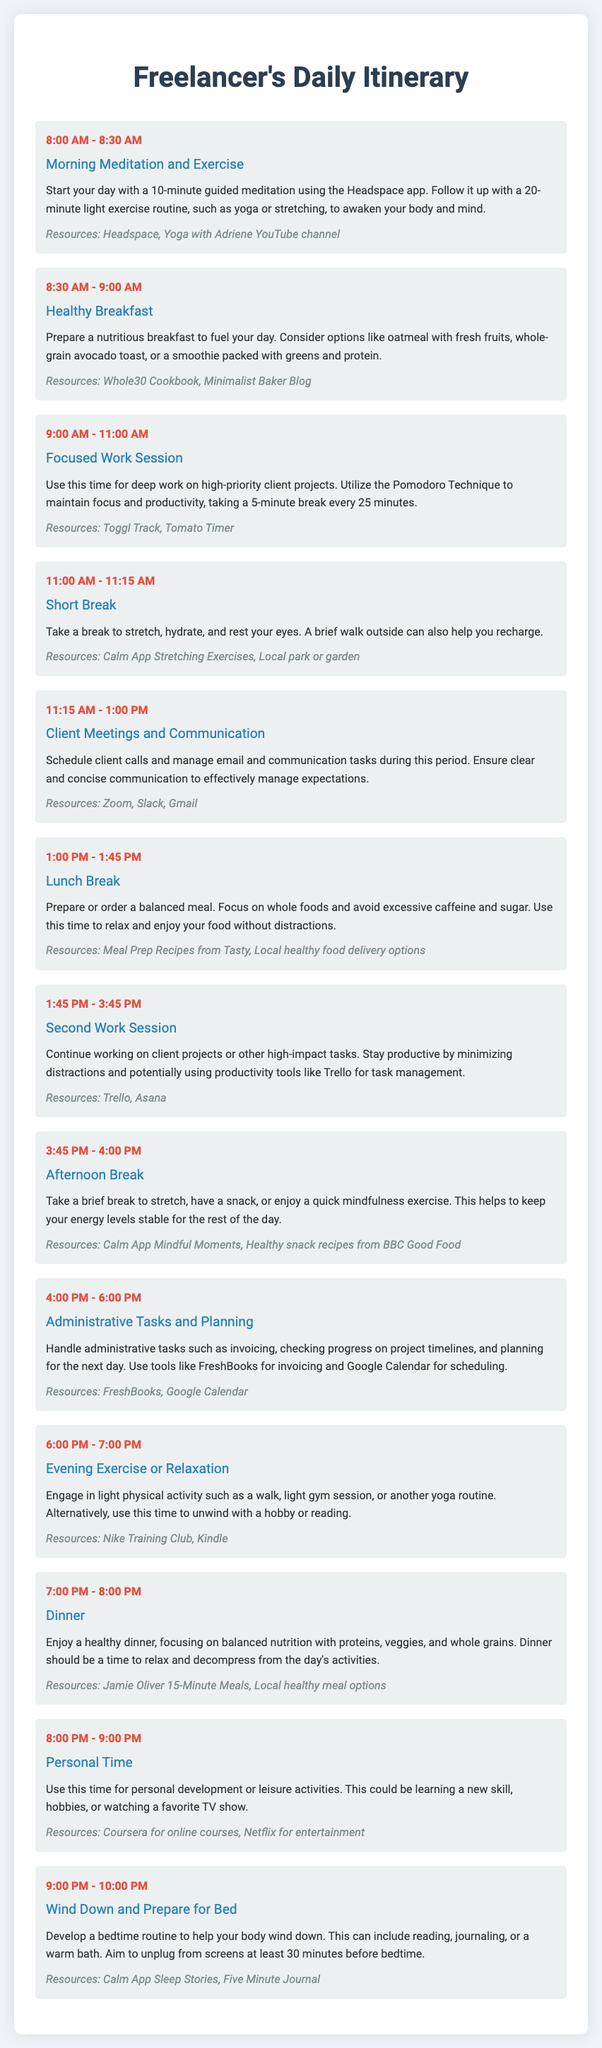What time does the morning meditation start? The morning meditation starts at 8:00 AM.
Answer: 8:00 AM How long is the focused work session? The focused work session lasts from 9:00 AM to 11:00 AM, which is 2 hours.
Answer: 2 hours What activity is scheduled for 1:45 PM to 3:45 PM? This time is allocated for the second work session.
Answer: Second work session What resources are recommended for lunch break? The recommended resources are meal prep recipes from Tasty and local healthy food delivery options.
Answer: Meal Prep Recipes from Tasty, Local healthy food delivery options What is the main focus during the 4:00 PM to 6:00 PM slot? This time is primarily for handling administrative tasks and planning for the next day.
Answer: Administrative Tasks and Planning What can you do during personal time from 8:00 PM to 9:00 PM? During this time, you can engage in personal development or leisure activities.
Answer: Personal development or leisure activities How long is the evening exercise or relaxation period? The evening exercise or relaxation period lasts for 1 hour, from 6:00 PM to 7:00 PM.
Answer: 1 hour What is the goal for the wind-down period before bed? The goal is to develop a bedtime routine to help your body wind down.
Answer: Bedtime routine Which app is suggested for morning meditation? The suggested app for morning meditation is the Headspace app.
Answer: Headspace app 